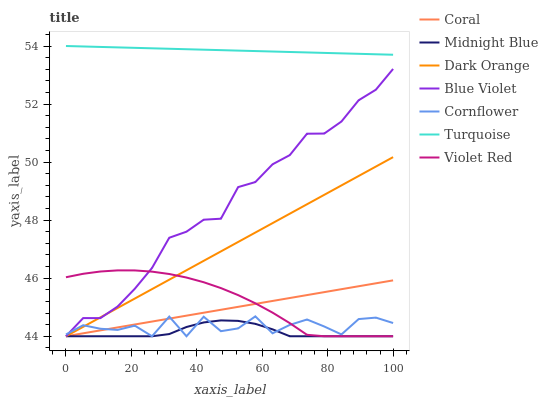Does Turquoise have the minimum area under the curve?
Answer yes or no. No. Does Midnight Blue have the maximum area under the curve?
Answer yes or no. No. Is Turquoise the smoothest?
Answer yes or no. No. Is Turquoise the roughest?
Answer yes or no. No. Does Turquoise have the lowest value?
Answer yes or no. No. Does Midnight Blue have the highest value?
Answer yes or no. No. Is Cornflower less than Turquoise?
Answer yes or no. Yes. Is Turquoise greater than Midnight Blue?
Answer yes or no. Yes. Does Cornflower intersect Turquoise?
Answer yes or no. No. 